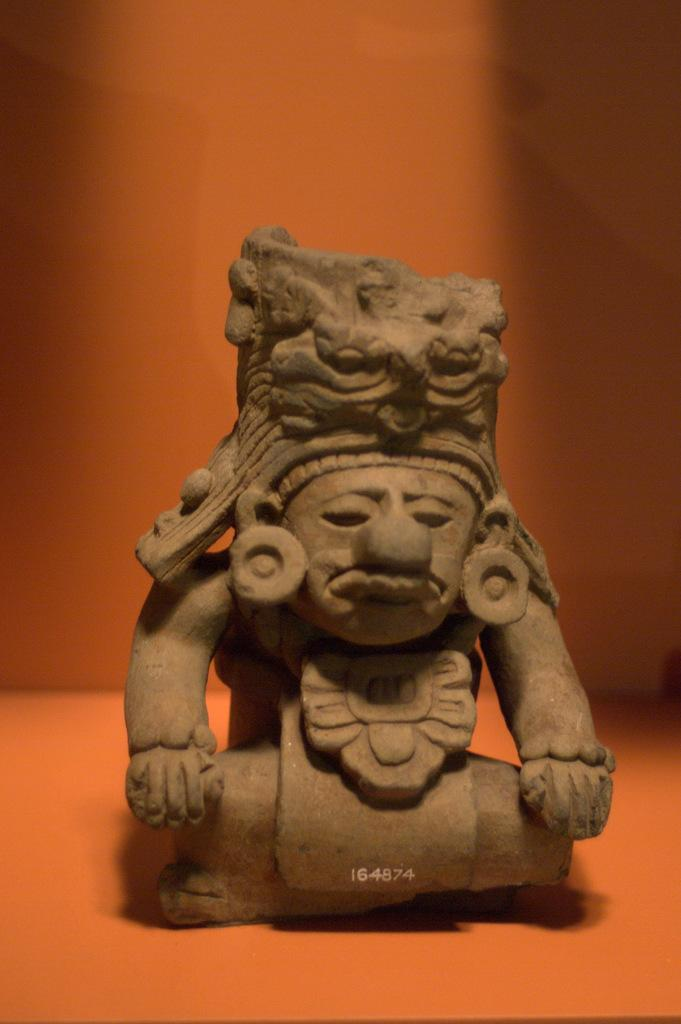What is the main object in the image? There is a small statue in the image. Where is the statue located? The statue is on the floor. What type of wrench is the statue holding in the image? There is no wrench present in the image, and the statue is not holding anything. 